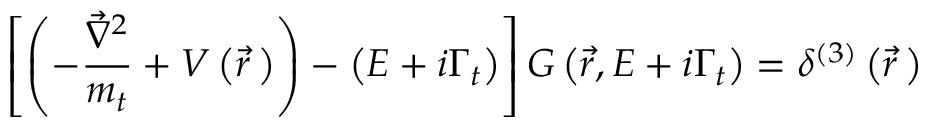Convert formula to latex. <formula><loc_0><loc_0><loc_500><loc_500>\left [ \left ( - \frac { \vec { \nabla } ^ { 2 } } { m _ { t } } + V \left ( \vec { r } \, \right ) \right ) - \left ( E + i \Gamma _ { t } \right ) \right ] G \left ( \vec { r } , E + i \Gamma _ { t } \right ) = \delta ^ { ( 3 ) } \left ( \vec { r } \, \right )</formula> 